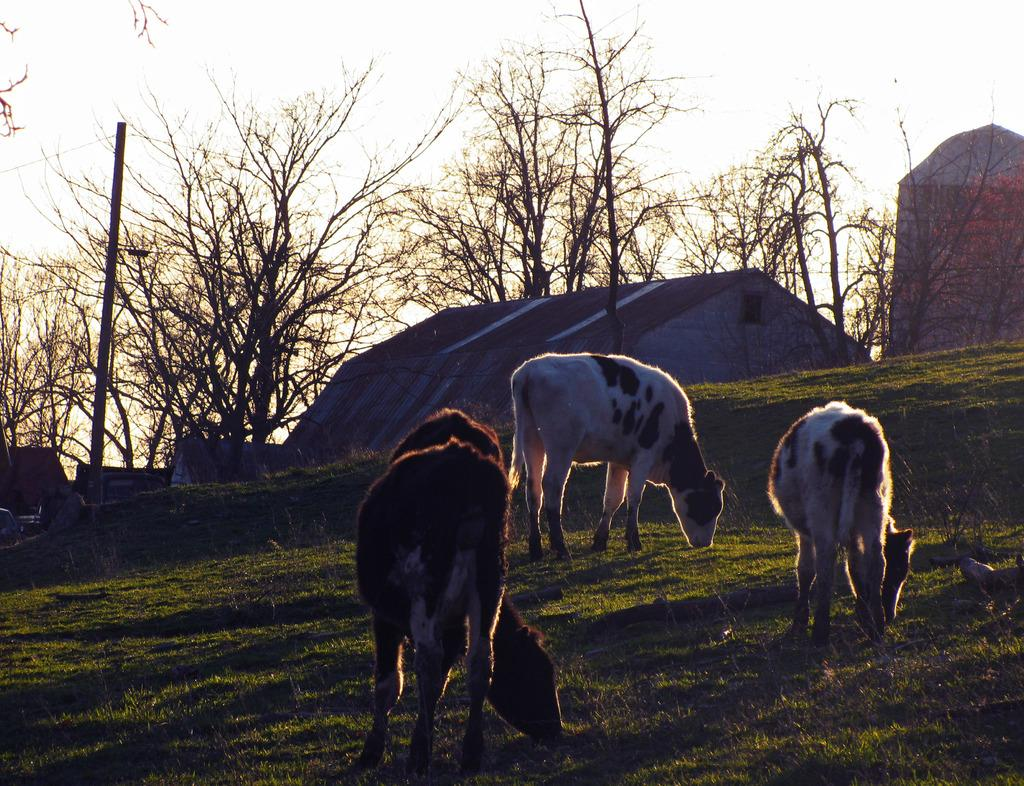What type of living organisms can be seen in the image? There are animals in the image. Where are the animals located? The animals are in a grassy land. What can be seen in the background of the image? There are houses and trees visible in the background of the image. What is visible at the top of the image? The sky is visible at the top of the image. What type of brass instrument is being played by the lawyer in the image? There is no lawyer or brass instrument present in the image. 